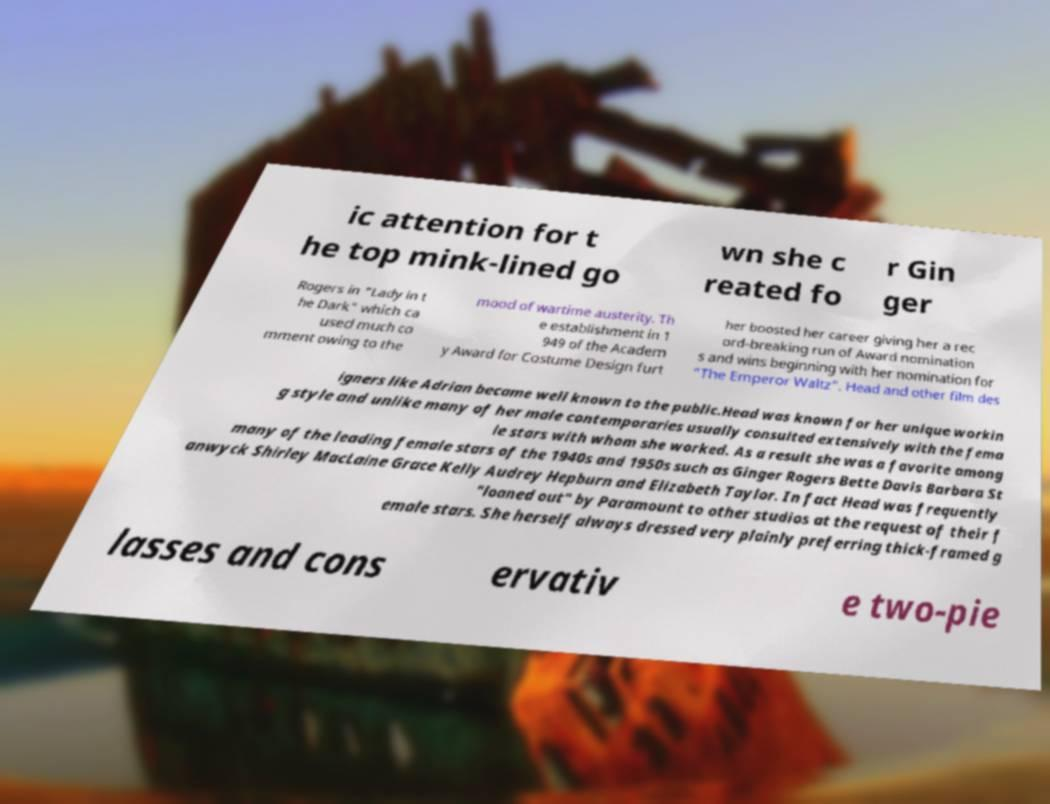Can you accurately transcribe the text from the provided image for me? ic attention for t he top mink-lined go wn she c reated fo r Gin ger Rogers in "Lady in t he Dark" which ca used much co mment owing to the mood of wartime austerity. Th e establishment in 1 949 of the Academ y Award for Costume Design furt her boosted her career giving her a rec ord-breaking run of Award nomination s and wins beginning with her nomination for "The Emperor Waltz". Head and other film des igners like Adrian became well known to the public.Head was known for her unique workin g style and unlike many of her male contemporaries usually consulted extensively with the fema le stars with whom she worked. As a result she was a favorite among many of the leading female stars of the 1940s and 1950s such as Ginger Rogers Bette Davis Barbara St anwyck Shirley MacLaine Grace Kelly Audrey Hepburn and Elizabeth Taylor. In fact Head was frequently "loaned out" by Paramount to other studios at the request of their f emale stars. She herself always dressed very plainly preferring thick-framed g lasses and cons ervativ e two-pie 